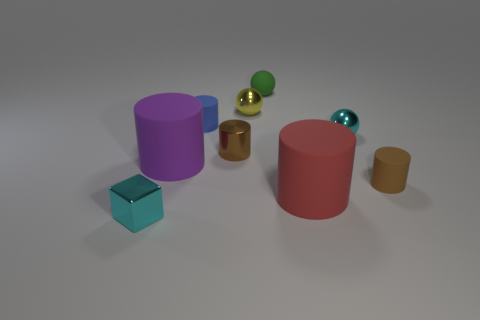Subtract all red cylinders. How many cylinders are left? 4 Subtract all blue matte cylinders. How many cylinders are left? 4 Subtract 2 cylinders. How many cylinders are left? 3 Subtract all yellow cylinders. Subtract all cyan blocks. How many cylinders are left? 5 Add 1 metal balls. How many objects exist? 10 Subtract all spheres. How many objects are left? 6 Subtract all small green metal things. Subtract all small brown metallic things. How many objects are left? 8 Add 9 small yellow things. How many small yellow things are left? 10 Add 8 gray shiny blocks. How many gray shiny blocks exist? 8 Subtract 1 blue cylinders. How many objects are left? 8 